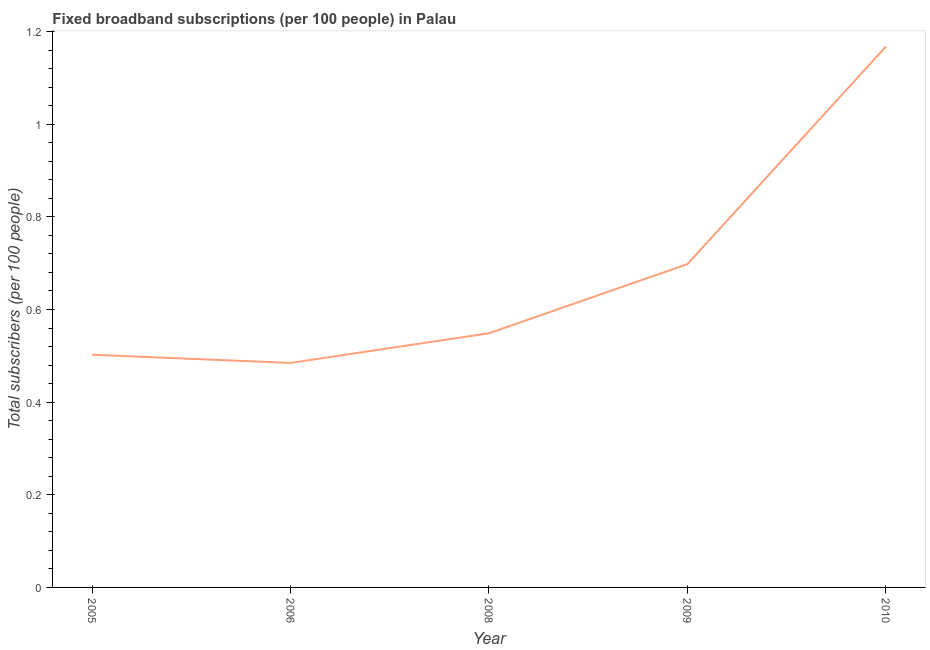What is the total number of fixed broadband subscriptions in 2006?
Keep it short and to the point. 0.48. Across all years, what is the maximum total number of fixed broadband subscriptions?
Offer a terse response. 1.17. Across all years, what is the minimum total number of fixed broadband subscriptions?
Give a very brief answer. 0.48. In which year was the total number of fixed broadband subscriptions maximum?
Make the answer very short. 2010. In which year was the total number of fixed broadband subscriptions minimum?
Make the answer very short. 2006. What is the sum of the total number of fixed broadband subscriptions?
Ensure brevity in your answer.  3.4. What is the difference between the total number of fixed broadband subscriptions in 2005 and 2010?
Offer a very short reply. -0.67. What is the average total number of fixed broadband subscriptions per year?
Make the answer very short. 0.68. What is the median total number of fixed broadband subscriptions?
Your response must be concise. 0.55. Do a majority of the years between 2006 and 2005 (inclusive) have total number of fixed broadband subscriptions greater than 0.52 ?
Ensure brevity in your answer.  No. What is the ratio of the total number of fixed broadband subscriptions in 2006 to that in 2008?
Your answer should be compact. 0.88. Is the total number of fixed broadband subscriptions in 2008 less than that in 2010?
Give a very brief answer. Yes. Is the difference between the total number of fixed broadband subscriptions in 2005 and 2006 greater than the difference between any two years?
Give a very brief answer. No. What is the difference between the highest and the second highest total number of fixed broadband subscriptions?
Your response must be concise. 0.47. What is the difference between the highest and the lowest total number of fixed broadband subscriptions?
Offer a terse response. 0.68. How many years are there in the graph?
Ensure brevity in your answer.  5. Are the values on the major ticks of Y-axis written in scientific E-notation?
Keep it short and to the point. No. Does the graph contain any zero values?
Your answer should be compact. No. What is the title of the graph?
Your response must be concise. Fixed broadband subscriptions (per 100 people) in Palau. What is the label or title of the X-axis?
Offer a terse response. Year. What is the label or title of the Y-axis?
Your answer should be compact. Total subscribers (per 100 people). What is the Total subscribers (per 100 people) in 2005?
Give a very brief answer. 0.5. What is the Total subscribers (per 100 people) in 2006?
Give a very brief answer. 0.48. What is the Total subscribers (per 100 people) in 2008?
Make the answer very short. 0.55. What is the Total subscribers (per 100 people) in 2009?
Keep it short and to the point. 0.7. What is the Total subscribers (per 100 people) of 2010?
Offer a very short reply. 1.17. What is the difference between the Total subscribers (per 100 people) in 2005 and 2006?
Your response must be concise. 0.02. What is the difference between the Total subscribers (per 100 people) in 2005 and 2008?
Your answer should be very brief. -0.05. What is the difference between the Total subscribers (per 100 people) in 2005 and 2009?
Offer a terse response. -0.2. What is the difference between the Total subscribers (per 100 people) in 2005 and 2010?
Give a very brief answer. -0.67. What is the difference between the Total subscribers (per 100 people) in 2006 and 2008?
Offer a very short reply. -0.06. What is the difference between the Total subscribers (per 100 people) in 2006 and 2009?
Keep it short and to the point. -0.21. What is the difference between the Total subscribers (per 100 people) in 2006 and 2010?
Provide a short and direct response. -0.68. What is the difference between the Total subscribers (per 100 people) in 2008 and 2009?
Make the answer very short. -0.15. What is the difference between the Total subscribers (per 100 people) in 2008 and 2010?
Give a very brief answer. -0.62. What is the difference between the Total subscribers (per 100 people) in 2009 and 2010?
Offer a terse response. -0.47. What is the ratio of the Total subscribers (per 100 people) in 2005 to that in 2006?
Provide a short and direct response. 1.04. What is the ratio of the Total subscribers (per 100 people) in 2005 to that in 2008?
Your response must be concise. 0.92. What is the ratio of the Total subscribers (per 100 people) in 2005 to that in 2009?
Provide a short and direct response. 0.72. What is the ratio of the Total subscribers (per 100 people) in 2005 to that in 2010?
Provide a short and direct response. 0.43. What is the ratio of the Total subscribers (per 100 people) in 2006 to that in 2008?
Offer a terse response. 0.88. What is the ratio of the Total subscribers (per 100 people) in 2006 to that in 2009?
Offer a very short reply. 0.69. What is the ratio of the Total subscribers (per 100 people) in 2006 to that in 2010?
Give a very brief answer. 0.41. What is the ratio of the Total subscribers (per 100 people) in 2008 to that in 2009?
Your response must be concise. 0.79. What is the ratio of the Total subscribers (per 100 people) in 2008 to that in 2010?
Your response must be concise. 0.47. What is the ratio of the Total subscribers (per 100 people) in 2009 to that in 2010?
Provide a succinct answer. 0.6. 